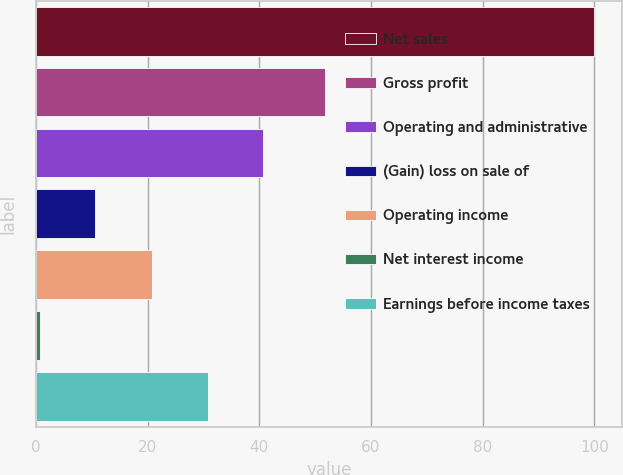Convert chart. <chart><loc_0><loc_0><loc_500><loc_500><bar_chart><fcel>Net sales<fcel>Gross profit<fcel>Operating and administrative<fcel>(Gain) loss on sale of<fcel>Operating income<fcel>Net interest income<fcel>Earnings before income taxes<nl><fcel>100<fcel>51.8<fcel>40.66<fcel>10.59<fcel>20.8<fcel>0.65<fcel>30.73<nl></chart> 